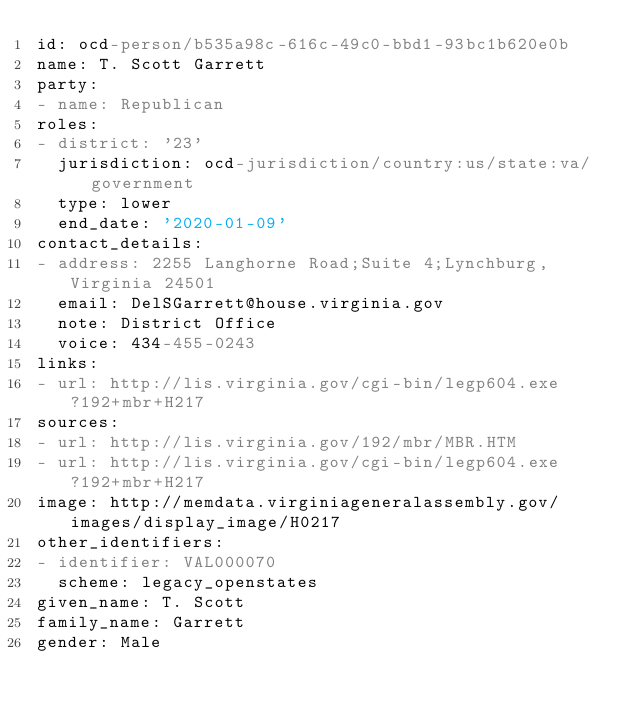Convert code to text. <code><loc_0><loc_0><loc_500><loc_500><_YAML_>id: ocd-person/b535a98c-616c-49c0-bbd1-93bc1b620e0b
name: T. Scott Garrett
party:
- name: Republican
roles:
- district: '23'
  jurisdiction: ocd-jurisdiction/country:us/state:va/government
  type: lower
  end_date: '2020-01-09'
contact_details:
- address: 2255 Langhorne Road;Suite 4;Lynchburg, Virginia 24501
  email: DelSGarrett@house.virginia.gov
  note: District Office
  voice: 434-455-0243
links:
- url: http://lis.virginia.gov/cgi-bin/legp604.exe?192+mbr+H217
sources:
- url: http://lis.virginia.gov/192/mbr/MBR.HTM
- url: http://lis.virginia.gov/cgi-bin/legp604.exe?192+mbr+H217
image: http://memdata.virginiageneralassembly.gov/images/display_image/H0217
other_identifiers:
- identifier: VAL000070
  scheme: legacy_openstates
given_name: T. Scott
family_name: Garrett
gender: Male
</code> 